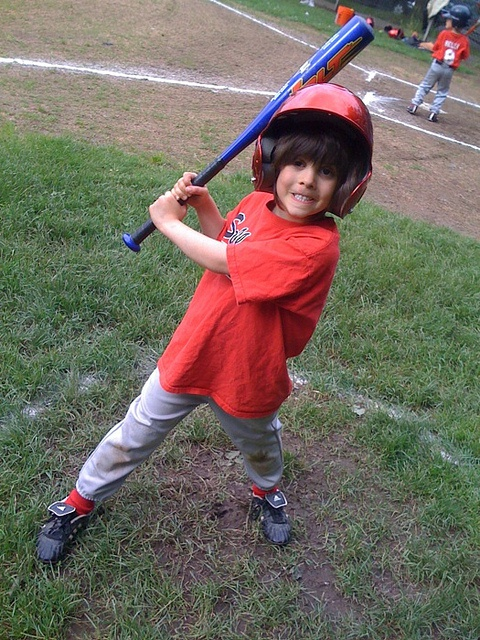Describe the objects in this image and their specific colors. I can see people in gray, black, salmon, and brown tones, baseball bat in gray, black, navy, darkblue, and blue tones, and people in gray, salmon, and darkgray tones in this image. 